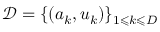<formula> <loc_0><loc_0><loc_500><loc_500>\mathcal { D } = \{ ( a _ { k } , u _ { k } ) \} _ { 1 \leqslant k \leqslant D }</formula> 